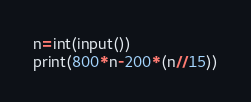<code> <loc_0><loc_0><loc_500><loc_500><_Python_>n=int(input())
print(800*n-200*(n//15))</code> 